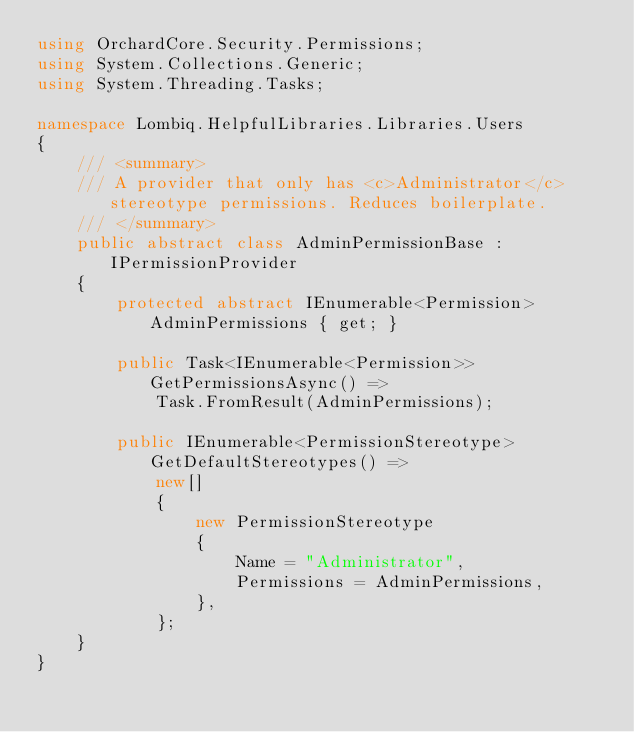<code> <loc_0><loc_0><loc_500><loc_500><_C#_>using OrchardCore.Security.Permissions;
using System.Collections.Generic;
using System.Threading.Tasks;

namespace Lombiq.HelpfulLibraries.Libraries.Users
{
    /// <summary>
    /// A provider that only has <c>Administrator</c> stereotype permissions. Reduces boilerplate.
    /// </summary>
    public abstract class AdminPermissionBase : IPermissionProvider
    {
        protected abstract IEnumerable<Permission> AdminPermissions { get; }

        public Task<IEnumerable<Permission>> GetPermissionsAsync() =>
            Task.FromResult(AdminPermissions);

        public IEnumerable<PermissionStereotype> GetDefaultStereotypes() =>
            new[]
            {
                new PermissionStereotype
                {
                    Name = "Administrator",
                    Permissions = AdminPermissions,
                },
            };
    }
}
</code> 